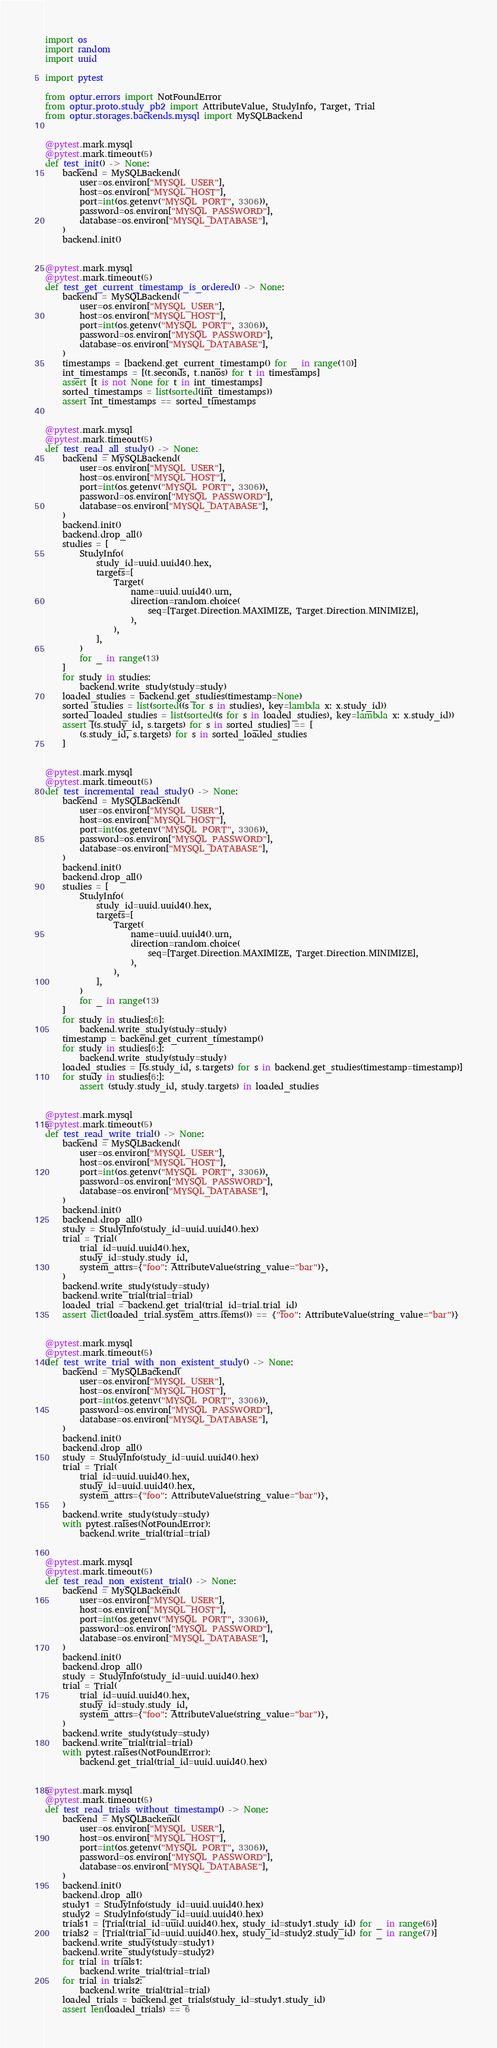<code> <loc_0><loc_0><loc_500><loc_500><_Python_>import os
import random
import uuid

import pytest

from optur.errors import NotFoundError
from optur.proto.study_pb2 import AttributeValue, StudyInfo, Target, Trial
from optur.storages.backends.mysql import MySQLBackend


@pytest.mark.mysql
@pytest.mark.timeout(5)
def test_init() -> None:
    backend = MySQLBackend(
        user=os.environ["MYSQL_USER"],
        host=os.environ["MYSQL_HOST"],
        port=int(os.getenv("MYSQL_PORT", 3306)),
        password=os.environ["MYSQL_PASSWORD"],
        database=os.environ["MYSQL_DATABASE"],
    )
    backend.init()


@pytest.mark.mysql
@pytest.mark.timeout(5)
def test_get_current_timestamp_is_ordered() -> None:
    backend = MySQLBackend(
        user=os.environ["MYSQL_USER"],
        host=os.environ["MYSQL_HOST"],
        port=int(os.getenv("MYSQL_PORT", 3306)),
        password=os.environ["MYSQL_PASSWORD"],
        database=os.environ["MYSQL_DATABASE"],
    )
    timestamps = [backend.get_current_timestamp() for _ in range(10)]
    int_timestamps = [(t.seconds, t.nanos) for t in timestamps]
    assert [t is not None for t in int_timestamps]
    sorted_timestamps = list(sorted(int_timestamps))
    assert int_timestamps == sorted_timestamps


@pytest.mark.mysql
@pytest.mark.timeout(5)
def test_read_all_study() -> None:
    backend = MySQLBackend(
        user=os.environ["MYSQL_USER"],
        host=os.environ["MYSQL_HOST"],
        port=int(os.getenv("MYSQL_PORT", 3306)),
        password=os.environ["MYSQL_PASSWORD"],
        database=os.environ["MYSQL_DATABASE"],
    )
    backend.init()
    backend.drop_all()
    studies = [
        StudyInfo(
            study_id=uuid.uuid4().hex,
            targets=[
                Target(
                    name=uuid.uuid4().urn,
                    direction=random.choice(
                        seq=[Target.Direction.MAXIMIZE, Target.Direction.MINIMIZE],
                    ),
                ),
            ],
        )
        for _ in range(13)
    ]
    for study in studies:
        backend.write_study(study=study)
    loaded_studies = backend.get_studies(timestamp=None)
    sorted_studies = list(sorted((s for s in studies), key=lambda x: x.study_id))
    sorted_loaded_studies = list(sorted((s for s in loaded_studies), key=lambda x: x.study_id))
    assert [(s.study_id, s.targets) for s in sorted_studies] == [
        (s.study_id, s.targets) for s in sorted_loaded_studies
    ]


@pytest.mark.mysql
@pytest.mark.timeout(5)
def test_incremental_read_study() -> None:
    backend = MySQLBackend(
        user=os.environ["MYSQL_USER"],
        host=os.environ["MYSQL_HOST"],
        port=int(os.getenv("MYSQL_PORT", 3306)),
        password=os.environ["MYSQL_PASSWORD"],
        database=os.environ["MYSQL_DATABASE"],
    )
    backend.init()
    backend.drop_all()
    studies = [
        StudyInfo(
            study_id=uuid.uuid4().hex,
            targets=[
                Target(
                    name=uuid.uuid4().urn,
                    direction=random.choice(
                        seq=[Target.Direction.MAXIMIZE, Target.Direction.MINIMIZE],
                    ),
                ),
            ],
        )
        for _ in range(13)
    ]
    for study in studies[:6]:
        backend.write_study(study=study)
    timestamp = backend.get_current_timestamp()
    for study in studies[6:]:
        backend.write_study(study=study)
    loaded_studies = [(s.study_id, s.targets) for s in backend.get_studies(timestamp=timestamp)]
    for study in studies[6:]:
        assert (study.study_id, study.targets) in loaded_studies


@pytest.mark.mysql
@pytest.mark.timeout(5)
def test_read_write_trial() -> None:
    backend = MySQLBackend(
        user=os.environ["MYSQL_USER"],
        host=os.environ["MYSQL_HOST"],
        port=int(os.getenv("MYSQL_PORT", 3306)),
        password=os.environ["MYSQL_PASSWORD"],
        database=os.environ["MYSQL_DATABASE"],
    )
    backend.init()
    backend.drop_all()
    study = StudyInfo(study_id=uuid.uuid4().hex)
    trial = Trial(
        trial_id=uuid.uuid4().hex,
        study_id=study.study_id,
        system_attrs={"foo": AttributeValue(string_value="bar")},
    )
    backend.write_study(study=study)
    backend.write_trial(trial=trial)
    loaded_trial = backend.get_trial(trial_id=trial.trial_id)
    assert dict(loaded_trial.system_attrs.items()) == {"foo": AttributeValue(string_value="bar")}


@pytest.mark.mysql
@pytest.mark.timeout(5)
def test_write_trial_with_non_existent_study() -> None:
    backend = MySQLBackend(
        user=os.environ["MYSQL_USER"],
        host=os.environ["MYSQL_HOST"],
        port=int(os.getenv("MYSQL_PORT", 3306)),
        password=os.environ["MYSQL_PASSWORD"],
        database=os.environ["MYSQL_DATABASE"],
    )
    backend.init()
    backend.drop_all()
    study = StudyInfo(study_id=uuid.uuid4().hex)
    trial = Trial(
        trial_id=uuid.uuid4().hex,
        study_id=uuid.uuid4().hex,
        system_attrs={"foo": AttributeValue(string_value="bar")},
    )
    backend.write_study(study=study)
    with pytest.raises(NotFoundError):
        backend.write_trial(trial=trial)


@pytest.mark.mysql
@pytest.mark.timeout(5)
def test_read_non_existent_trial() -> None:
    backend = MySQLBackend(
        user=os.environ["MYSQL_USER"],
        host=os.environ["MYSQL_HOST"],
        port=int(os.getenv("MYSQL_PORT", 3306)),
        password=os.environ["MYSQL_PASSWORD"],
        database=os.environ["MYSQL_DATABASE"],
    )
    backend.init()
    backend.drop_all()
    study = StudyInfo(study_id=uuid.uuid4().hex)
    trial = Trial(
        trial_id=uuid.uuid4().hex,
        study_id=study.study_id,
        system_attrs={"foo": AttributeValue(string_value="bar")},
    )
    backend.write_study(study=study)
    backend.write_trial(trial=trial)
    with pytest.raises(NotFoundError):
        backend.get_trial(trial_id=uuid.uuid4().hex)


@pytest.mark.mysql
@pytest.mark.timeout(5)
def test_read_trials_without_timestamp() -> None:
    backend = MySQLBackend(
        user=os.environ["MYSQL_USER"],
        host=os.environ["MYSQL_HOST"],
        port=int(os.getenv("MYSQL_PORT", 3306)),
        password=os.environ["MYSQL_PASSWORD"],
        database=os.environ["MYSQL_DATABASE"],
    )
    backend.init()
    backend.drop_all()
    study1 = StudyInfo(study_id=uuid.uuid4().hex)
    study2 = StudyInfo(study_id=uuid.uuid4().hex)
    trials1 = [Trial(trial_id=uuid.uuid4().hex, study_id=study1.study_id) for _ in range(6)]
    trials2 = [Trial(trial_id=uuid.uuid4().hex, study_id=study2.study_id) for _ in range(7)]
    backend.write_study(study=study1)
    backend.write_study(study=study2)
    for trial in trials1:
        backend.write_trial(trial=trial)
    for trial in trials2:
        backend.write_trial(trial=trial)
    loaded_trials = backend.get_trials(study_id=study1.study_id)
    assert len(loaded_trials) == 6</code> 